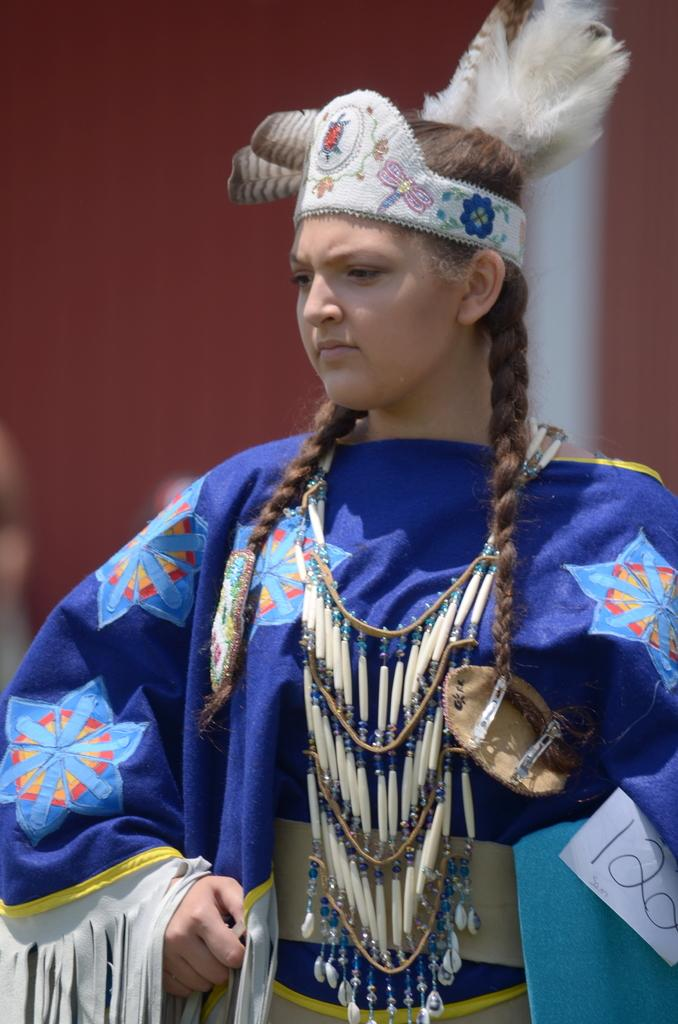Who is the main subject in the image? There is a girl in the image. What is the girl wearing? The girl is wearing a traditional blue color dress. Where is the girl positioned in the image? The girl is standing in the front. What direction is the girl looking? The girl is looking on the left side. How would you describe the background in the image? There is a red color blur background in the image. What type of behavior is the girl exhibiting in the image? The provided facts do not mention any specific behavior of the girl in the image. --- Facts: 1. There is a group of people in the image. 2. The people are holding hands. 3. The people are wearing matching outfits. 4. The background is a park. 5. There is a tree in the background. Absurd Topics: parrot, ocean, bicycle Conversation: How many people are in the image? There is a group of people in the image. What are the people doing in the image? The people are holding hands. What are the people wearing in the image? The people are wearing matching outfits. What can be seen in the background of the image? The background is a park, and there is a tree in the background. Reasoning: Let's think step by step in order to produce the conversation. We start by identifying the main subject in the image, which is the group of people. Then, we describe their actions, noting that they are holding hands. Next, we mention their appearance, focusing on the matching outfits. We also describe the background, which is a park with a tree. Each question is designed to elicit a specific detail about the image that is known from the provided facts. Absurd Question/Answer: Can you see a parrot flying in the background of the image? There is no mention of a parrot in the image; the background is a park with a tree. --- Facts: 1. There is a car in the image. 2. The car is red. 3. The car has four wheels. 4. The car has a sunroof. 5. The car has a spoiler. Absurd Topics: bird, ocean, bicycle Conversation: What is the main subject in the image? There is a car in the image. What color is the car? The car is red. How many wheels does the car have? The car has four wheels. What additional features does the car have? The car has a sunroof and a spoiler. Reasoning: Let's think step by step in order to produce the 